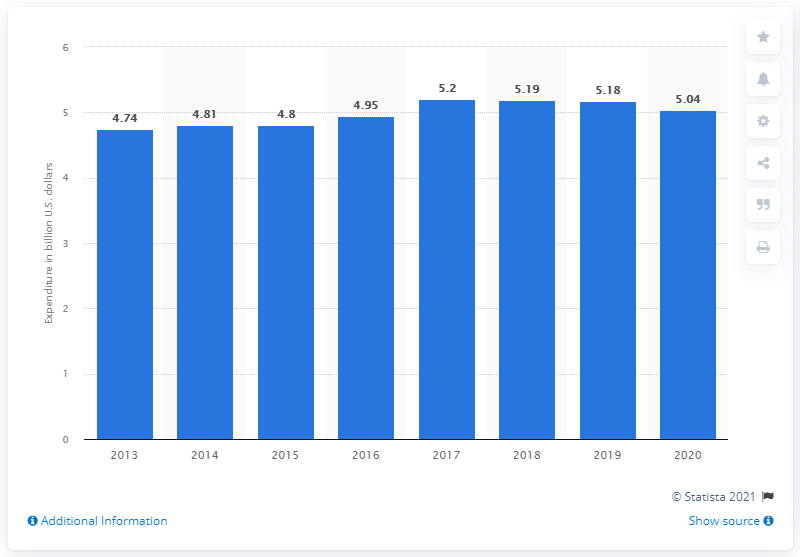Point out several critical features in this image. Chile's military expenditure in 2013 was 4.74. Chile spent 5.04 billion dollars on the military in 2020. 